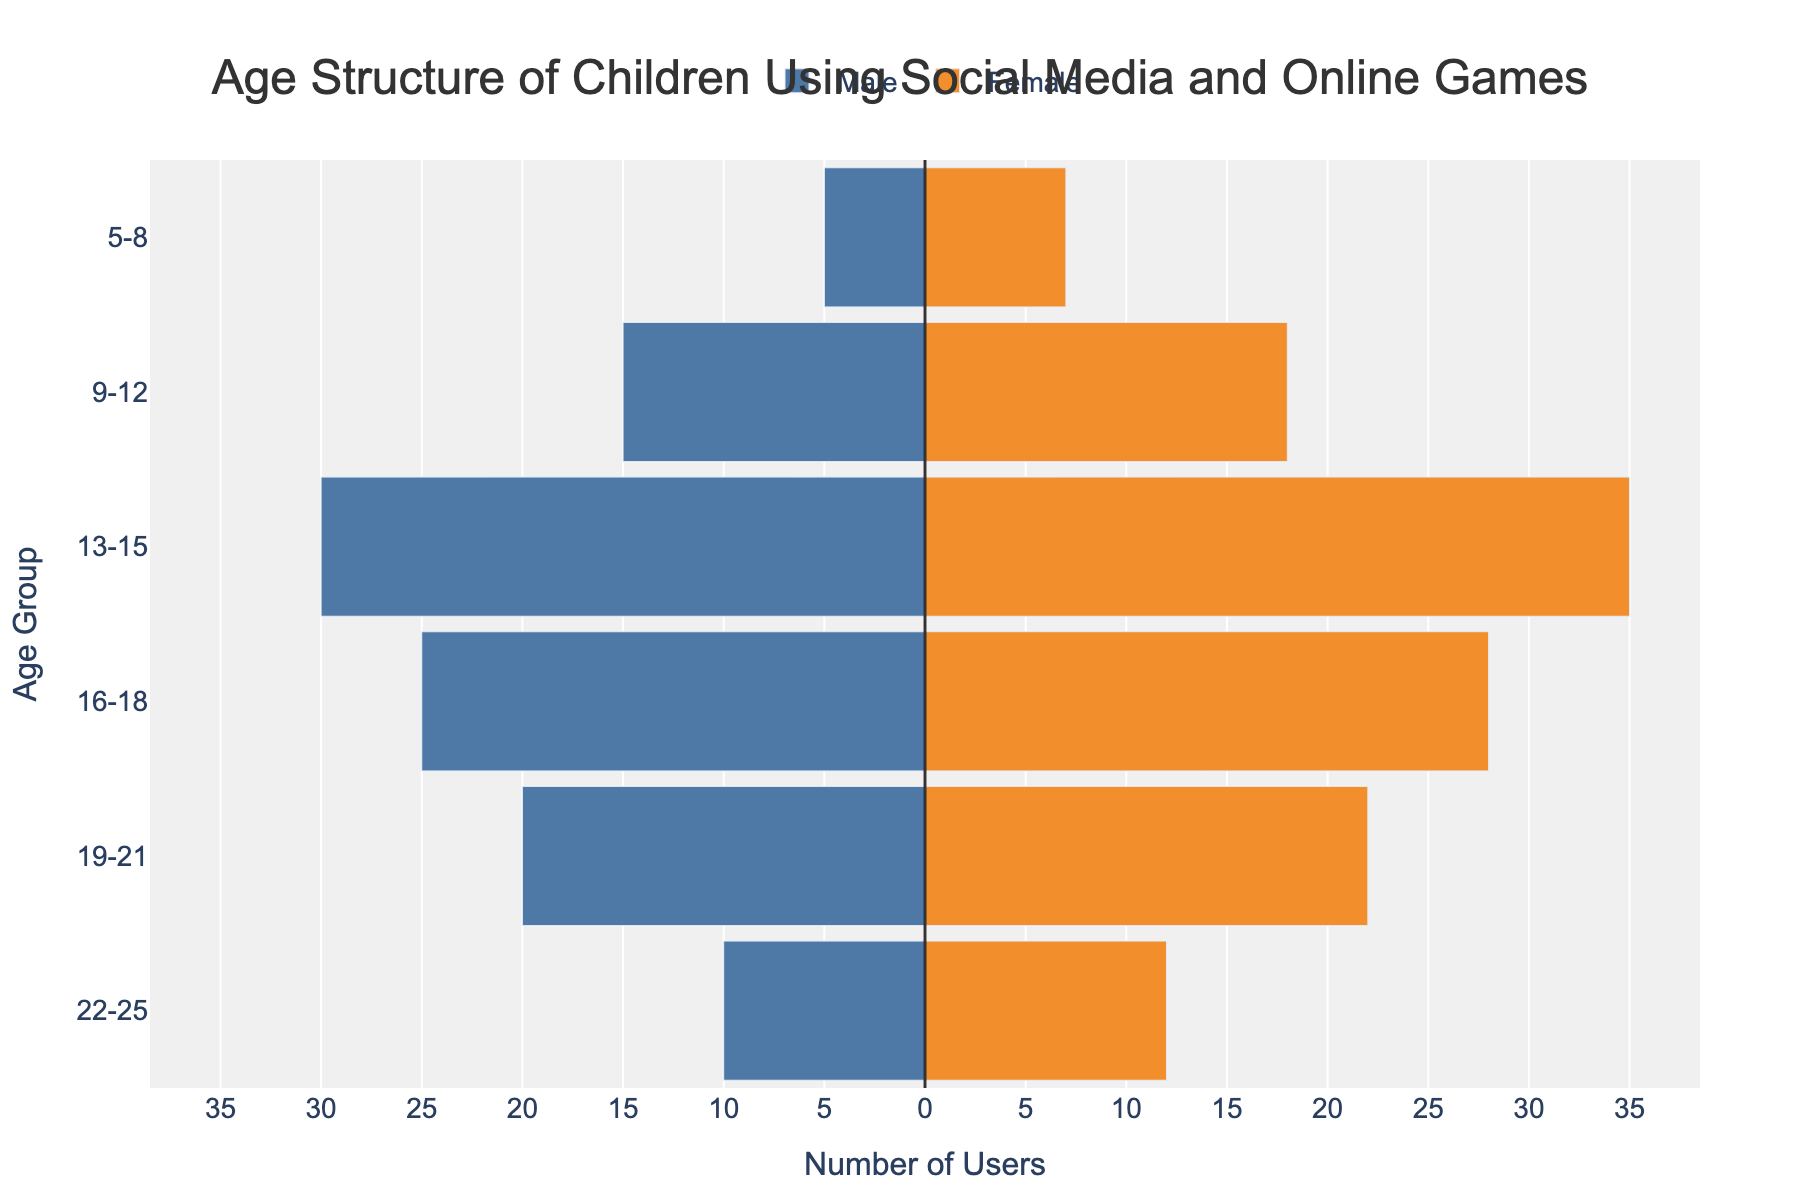What is the age group with the highest number of female users? The age group with the highest number of female users can be found by looking at the bar with the longest length for females. In the figure, the age group 13-15 has the tallest orange bar (representing females).
Answer: 13-15 Which gender has more users in the age group 16-18? Compare the lengths of the bars for males and females in the age group 16-18. The bar for females (orange) is taller than the bar for males (blue).
Answer: Female How many male and female users are in the age group 22-25 combined? To find the combined number of users, add the number of male and female users for the age group 22-25. The values are 10 male and 12 female. So, 10 + 12 = 22.
Answer: 22 Are there more male users in the 9-12 age group or female users in the 19-21 age group? Compare the bar lengths for males in the 9-12 age group and females in the 19-21 age group. The length of the male bar for 9-12 is 15, and the length of the female bar for 19-21 is 22.
Answer: Female users in the 19-21 age group What is the total number of users in the 13-15 age group? Add the number of male and female users in the 13-15 age group. The values are 30 male and 35 female. So, 30 + 35 = 65.
Answer: 65 How does the number of users in age group 5-8 compare to age group 16-18? Sum the number of users in each group and compare:
5-8: 5 (male) + 7 (female) = 12 
16-18: 25 (male) + 28 (female) = 53 
The age group 16-18 has significantly more users than the age group 5-8.
Answer: Age group 16-18 has more users Which age group has the smallest number of total users? Add the number of male and female users for each age group and find the smallest sum. Age group 5-8: 12, 9-12: 33, 13-15: 65, 16-18: 53, 19-21: 42, 22-25: 22. The age group 5-8 has the smallest total number users of 12.
Answer: 5-8 What is the average number of female users across all age groups? Sum the number of female users across all age groups and divide by the number of age groups: (7 + 18 + 35 + 28 + 22 + 12)/6 = 122/6 = 20.33.
Answer: 20.33 